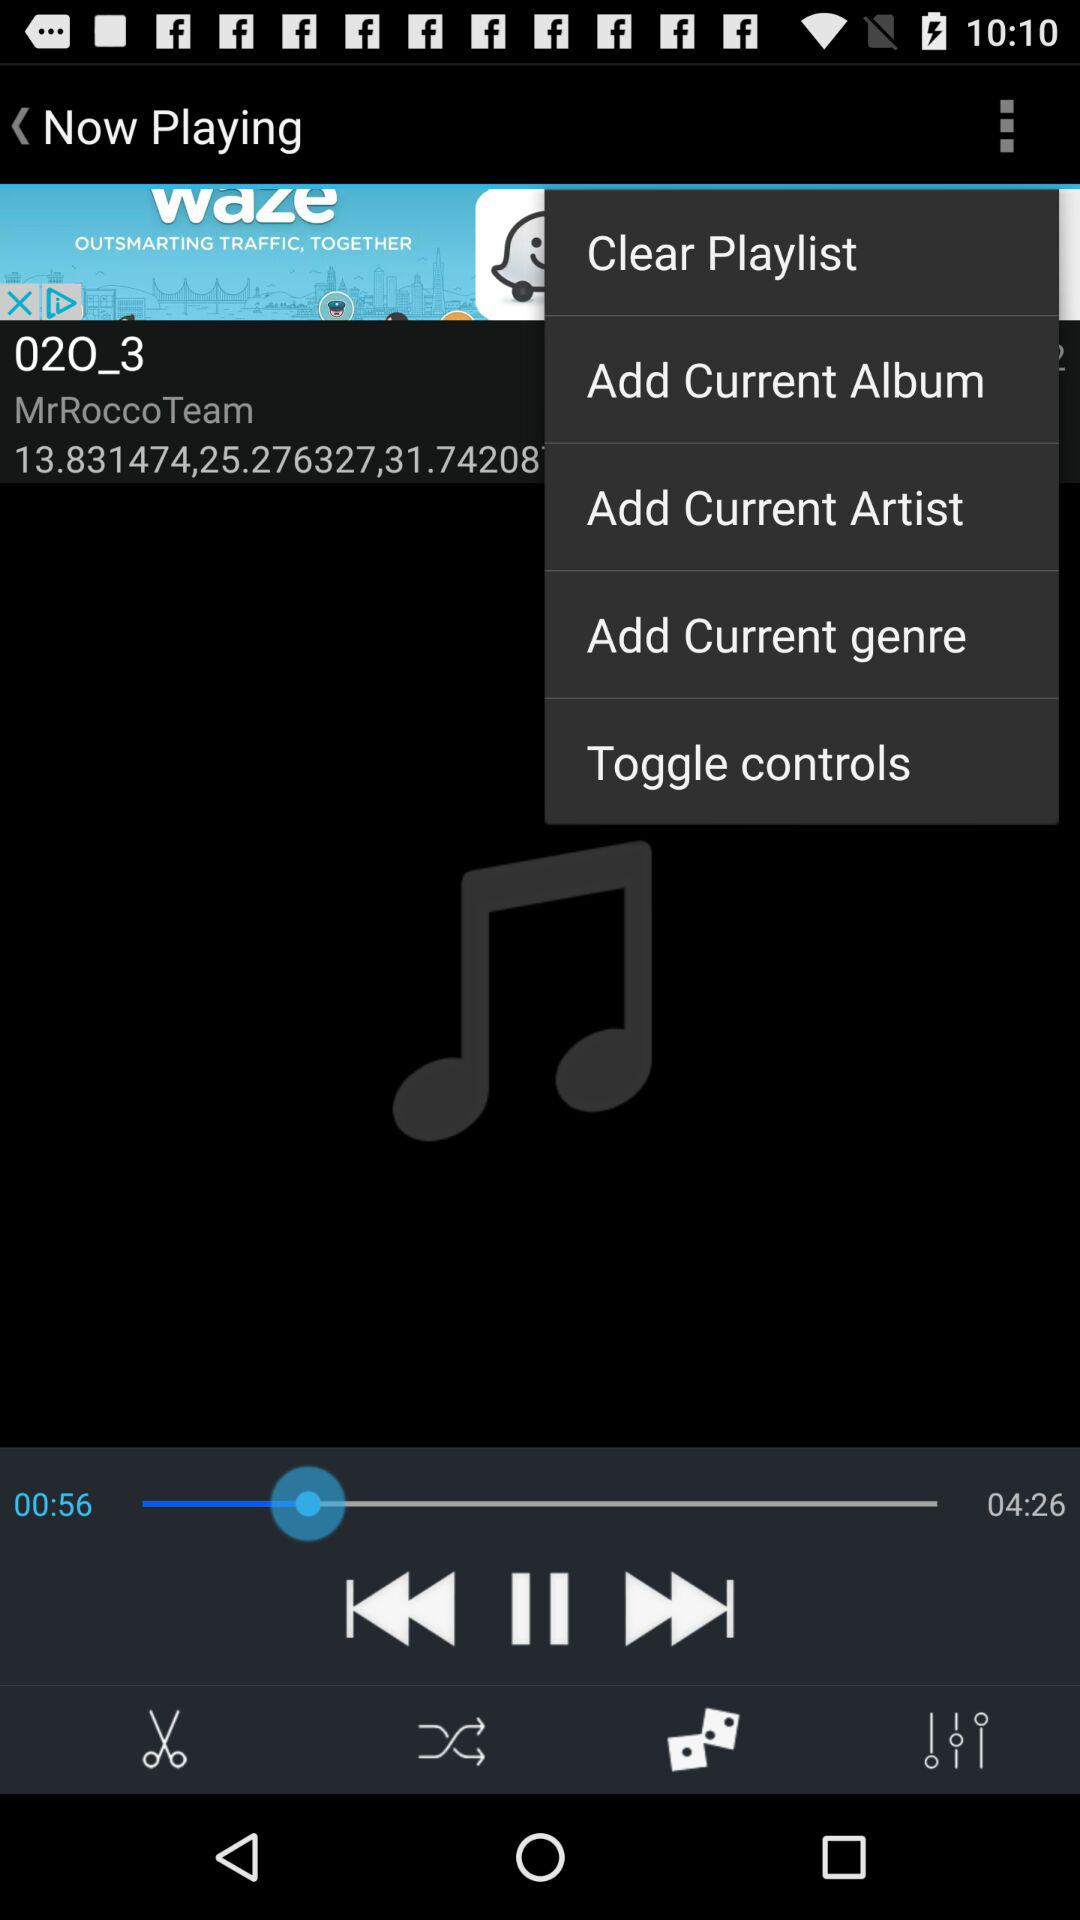What is the name of the audio? The name of the audio is 02O_3. 